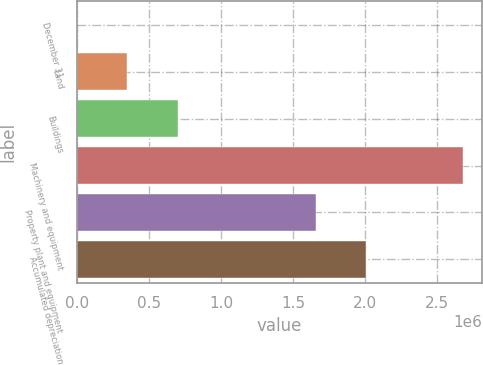<chart> <loc_0><loc_0><loc_500><loc_500><bar_chart><fcel>December 31<fcel>Land<fcel>Buildings<fcel>Machinery and equipment<fcel>Property plant and equipment<fcel>Accumulated depreciation<nl><fcel>2005<fcel>347646<fcel>699899<fcel>2.67684e+06<fcel>1.65914e+06<fcel>2.00478e+06<nl></chart> 